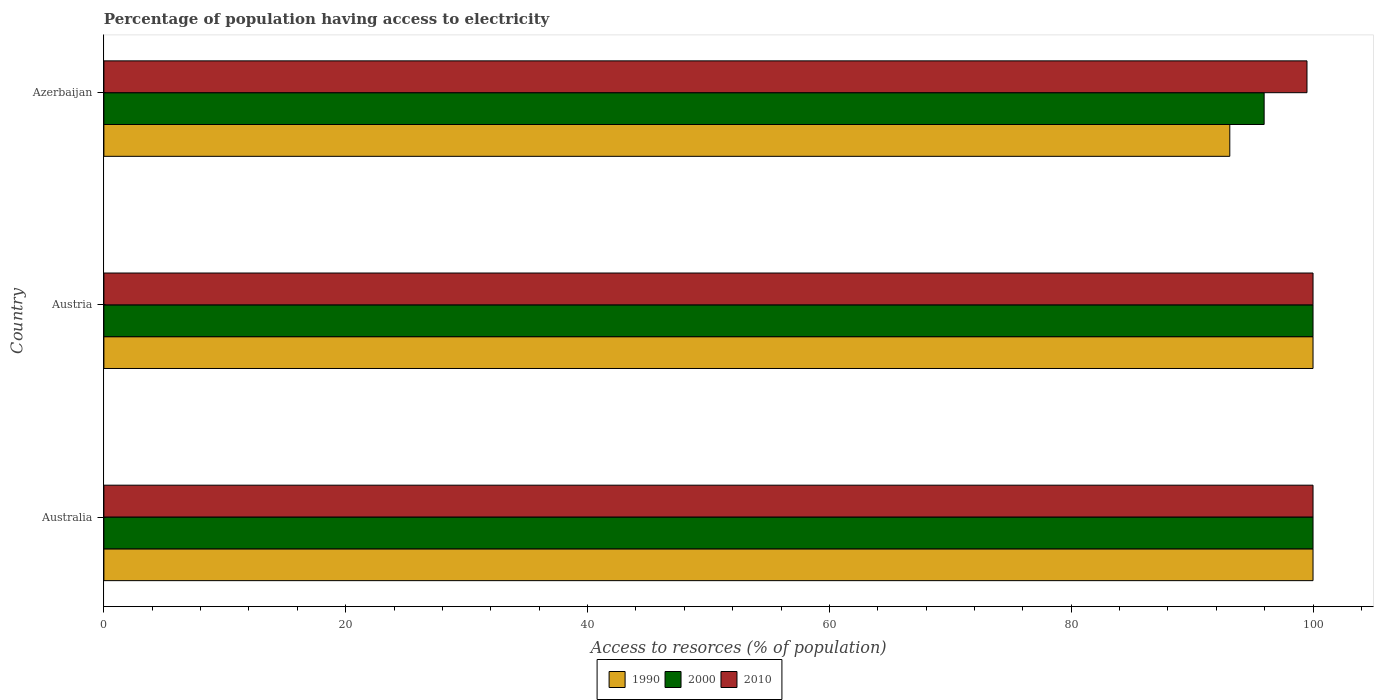How many different coloured bars are there?
Your response must be concise. 3. Are the number of bars per tick equal to the number of legend labels?
Provide a short and direct response. Yes. How many bars are there on the 2nd tick from the top?
Provide a short and direct response. 3. How many bars are there on the 3rd tick from the bottom?
Give a very brief answer. 3. What is the label of the 1st group of bars from the top?
Keep it short and to the point. Azerbaijan. What is the percentage of population having access to electricity in 2010 in Australia?
Provide a short and direct response. 100. Across all countries, what is the maximum percentage of population having access to electricity in 2010?
Your response must be concise. 100. Across all countries, what is the minimum percentage of population having access to electricity in 1990?
Offer a terse response. 93.12. In which country was the percentage of population having access to electricity in 2000 minimum?
Offer a terse response. Azerbaijan. What is the total percentage of population having access to electricity in 1990 in the graph?
Give a very brief answer. 293.12. What is the average percentage of population having access to electricity in 2010 per country?
Make the answer very short. 99.83. What is the difference between the percentage of population having access to electricity in 2010 and percentage of population having access to electricity in 2000 in Azerbaijan?
Make the answer very short. 3.54. In how many countries, is the percentage of population having access to electricity in 2010 greater than 96 %?
Offer a terse response. 3. What is the ratio of the percentage of population having access to electricity in 2000 in Austria to that in Azerbaijan?
Offer a terse response. 1.04. What is the difference between the highest and the lowest percentage of population having access to electricity in 2000?
Your answer should be very brief. 4.04. What does the 1st bar from the top in Austria represents?
Your response must be concise. 2010. What does the 1st bar from the bottom in Austria represents?
Your response must be concise. 1990. How many bars are there?
Provide a short and direct response. 9. How many countries are there in the graph?
Your answer should be compact. 3. Does the graph contain any zero values?
Offer a very short reply. No. Does the graph contain grids?
Offer a very short reply. No. Where does the legend appear in the graph?
Give a very brief answer. Bottom center. How many legend labels are there?
Offer a very short reply. 3. What is the title of the graph?
Ensure brevity in your answer.  Percentage of population having access to electricity. Does "1965" appear as one of the legend labels in the graph?
Offer a very short reply. No. What is the label or title of the X-axis?
Your answer should be very brief. Access to resorces (% of population). What is the label or title of the Y-axis?
Offer a terse response. Country. What is the Access to resorces (% of population) in 1990 in Australia?
Your answer should be compact. 100. What is the Access to resorces (% of population) in 2010 in Australia?
Provide a short and direct response. 100. What is the Access to resorces (% of population) of 1990 in Austria?
Offer a very short reply. 100. What is the Access to resorces (% of population) in 2010 in Austria?
Your answer should be very brief. 100. What is the Access to resorces (% of population) in 1990 in Azerbaijan?
Ensure brevity in your answer.  93.12. What is the Access to resorces (% of population) in 2000 in Azerbaijan?
Provide a short and direct response. 95.96. What is the Access to resorces (% of population) of 2010 in Azerbaijan?
Provide a short and direct response. 99.5. Across all countries, what is the maximum Access to resorces (% of population) in 2000?
Offer a very short reply. 100. Across all countries, what is the maximum Access to resorces (% of population) of 2010?
Your response must be concise. 100. Across all countries, what is the minimum Access to resorces (% of population) of 1990?
Give a very brief answer. 93.12. Across all countries, what is the minimum Access to resorces (% of population) in 2000?
Provide a short and direct response. 95.96. Across all countries, what is the minimum Access to resorces (% of population) of 2010?
Your answer should be compact. 99.5. What is the total Access to resorces (% of population) of 1990 in the graph?
Make the answer very short. 293.12. What is the total Access to resorces (% of population) in 2000 in the graph?
Provide a succinct answer. 295.96. What is the total Access to resorces (% of population) in 2010 in the graph?
Provide a short and direct response. 299.5. What is the difference between the Access to resorces (% of population) of 1990 in Australia and that in Austria?
Provide a short and direct response. 0. What is the difference between the Access to resorces (% of population) in 2000 in Australia and that in Austria?
Give a very brief answer. 0. What is the difference between the Access to resorces (% of population) in 1990 in Australia and that in Azerbaijan?
Provide a short and direct response. 6.88. What is the difference between the Access to resorces (% of population) in 2000 in Australia and that in Azerbaijan?
Make the answer very short. 4.04. What is the difference between the Access to resorces (% of population) of 2010 in Australia and that in Azerbaijan?
Ensure brevity in your answer.  0.5. What is the difference between the Access to resorces (% of population) of 1990 in Austria and that in Azerbaijan?
Give a very brief answer. 6.88. What is the difference between the Access to resorces (% of population) of 2000 in Austria and that in Azerbaijan?
Ensure brevity in your answer.  4.04. What is the difference between the Access to resorces (% of population) of 1990 in Australia and the Access to resorces (% of population) of 2000 in Austria?
Your answer should be compact. 0. What is the difference between the Access to resorces (% of population) of 1990 in Australia and the Access to resorces (% of population) of 2010 in Austria?
Offer a terse response. 0. What is the difference between the Access to resorces (% of population) in 1990 in Australia and the Access to resorces (% of population) in 2000 in Azerbaijan?
Ensure brevity in your answer.  4.04. What is the difference between the Access to resorces (% of population) of 1990 in Austria and the Access to resorces (% of population) of 2000 in Azerbaijan?
Your answer should be compact. 4.04. What is the difference between the Access to resorces (% of population) of 1990 in Austria and the Access to resorces (% of population) of 2010 in Azerbaijan?
Your response must be concise. 0.5. What is the average Access to resorces (% of population) of 1990 per country?
Offer a very short reply. 97.71. What is the average Access to resorces (% of population) in 2000 per country?
Offer a very short reply. 98.65. What is the average Access to resorces (% of population) in 2010 per country?
Offer a terse response. 99.83. What is the difference between the Access to resorces (% of population) of 1990 and Access to resorces (% of population) of 2000 in Australia?
Your answer should be compact. 0. What is the difference between the Access to resorces (% of population) in 1990 and Access to resorces (% of population) in 2010 in Australia?
Provide a succinct answer. 0. What is the difference between the Access to resorces (% of population) of 2000 and Access to resorces (% of population) of 2010 in Australia?
Make the answer very short. 0. What is the difference between the Access to resorces (% of population) of 1990 and Access to resorces (% of population) of 2000 in Azerbaijan?
Make the answer very short. -2.84. What is the difference between the Access to resorces (% of population) in 1990 and Access to resorces (% of population) in 2010 in Azerbaijan?
Keep it short and to the point. -6.38. What is the difference between the Access to resorces (% of population) in 2000 and Access to resorces (% of population) in 2010 in Azerbaijan?
Your answer should be compact. -3.54. What is the ratio of the Access to resorces (% of population) in 2000 in Australia to that in Austria?
Offer a terse response. 1. What is the ratio of the Access to resorces (% of population) in 2010 in Australia to that in Austria?
Provide a short and direct response. 1. What is the ratio of the Access to resorces (% of population) of 1990 in Australia to that in Azerbaijan?
Your answer should be compact. 1.07. What is the ratio of the Access to resorces (% of population) in 2000 in Australia to that in Azerbaijan?
Your answer should be very brief. 1.04. What is the ratio of the Access to resorces (% of population) in 2010 in Australia to that in Azerbaijan?
Make the answer very short. 1. What is the ratio of the Access to resorces (% of population) of 1990 in Austria to that in Azerbaijan?
Your answer should be very brief. 1.07. What is the ratio of the Access to resorces (% of population) of 2000 in Austria to that in Azerbaijan?
Your answer should be compact. 1.04. What is the ratio of the Access to resorces (% of population) of 2010 in Austria to that in Azerbaijan?
Your response must be concise. 1. What is the difference between the highest and the second highest Access to resorces (% of population) in 1990?
Ensure brevity in your answer.  0. What is the difference between the highest and the second highest Access to resorces (% of population) in 2000?
Give a very brief answer. 0. What is the difference between the highest and the lowest Access to resorces (% of population) of 1990?
Provide a short and direct response. 6.88. What is the difference between the highest and the lowest Access to resorces (% of population) of 2000?
Your answer should be compact. 4.04. What is the difference between the highest and the lowest Access to resorces (% of population) of 2010?
Ensure brevity in your answer.  0.5. 